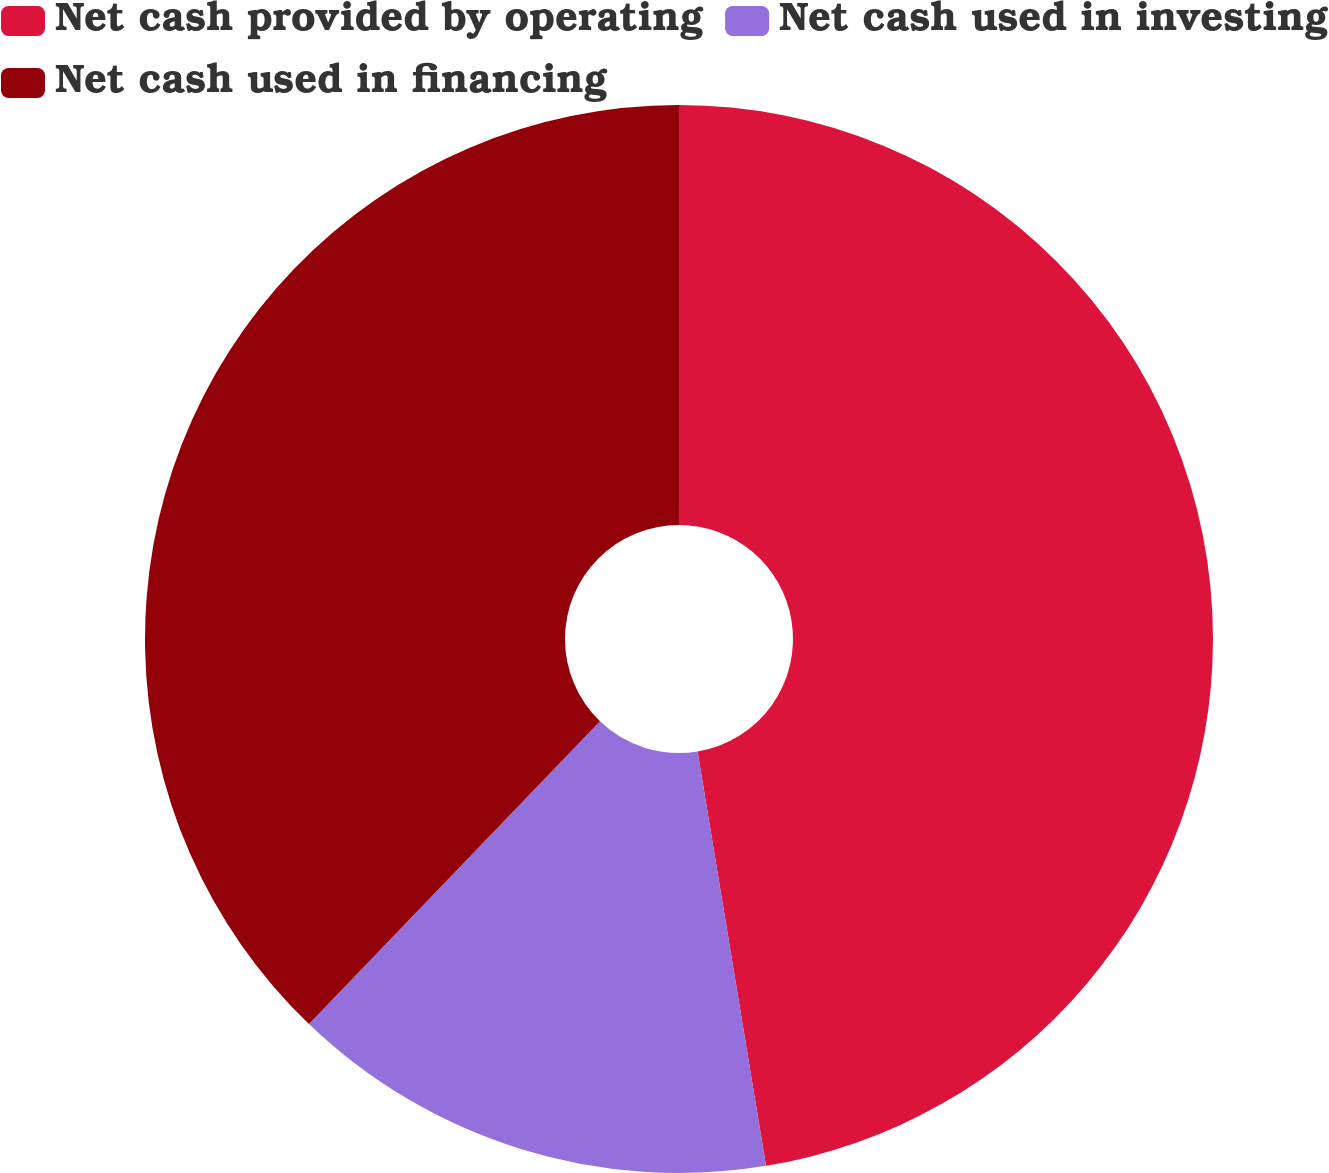Convert chart to OTSL. <chart><loc_0><loc_0><loc_500><loc_500><pie_chart><fcel>Net cash provided by operating<fcel>Net cash used in investing<fcel>Net cash used in financing<nl><fcel>47.4%<fcel>14.79%<fcel>37.82%<nl></chart> 